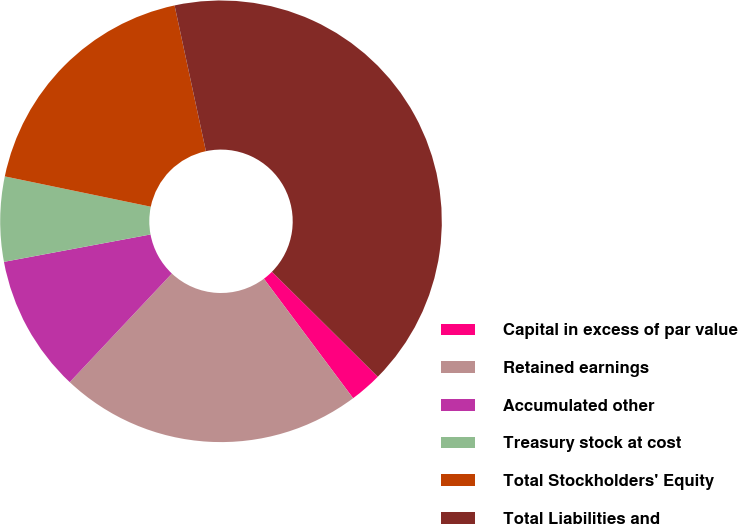<chart> <loc_0><loc_0><loc_500><loc_500><pie_chart><fcel>Capital in excess of par value<fcel>Retained earnings<fcel>Accumulated other<fcel>Treasury stock at cost<fcel>Total Stockholders' Equity<fcel>Total Liabilities and<nl><fcel>2.36%<fcel>22.22%<fcel>10.05%<fcel>6.2%<fcel>18.37%<fcel>40.81%<nl></chart> 